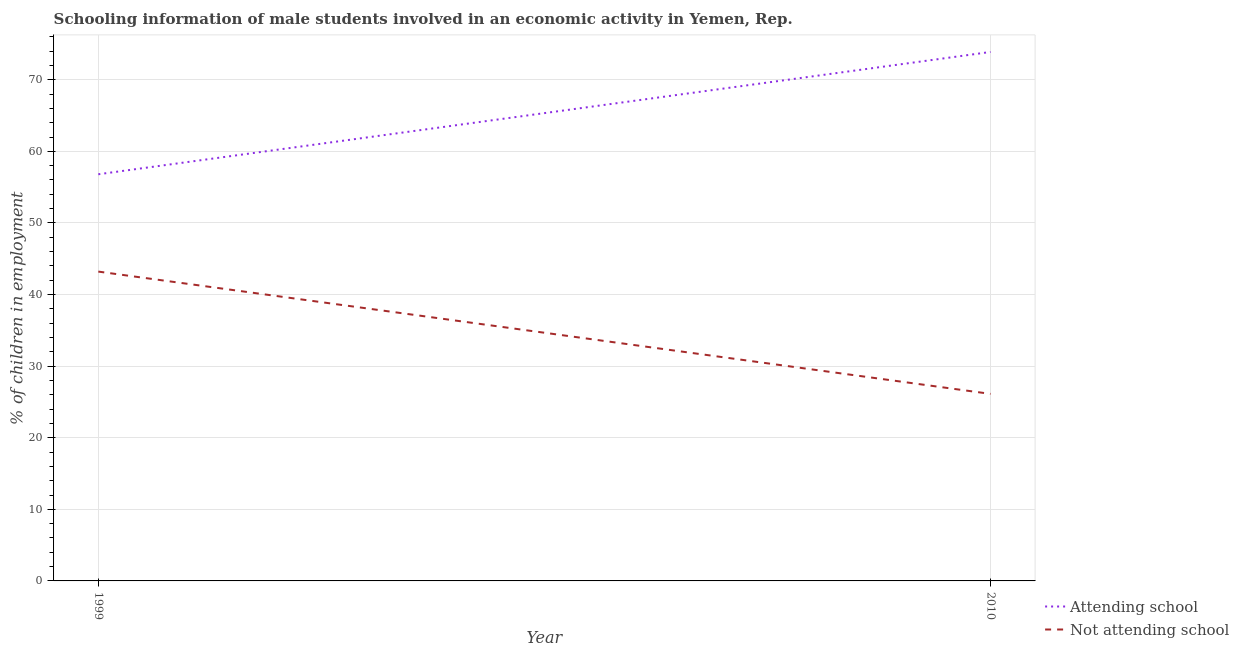What is the percentage of employed males who are not attending school in 2010?
Your response must be concise. 26.12. Across all years, what is the maximum percentage of employed males who are not attending school?
Ensure brevity in your answer.  43.2. Across all years, what is the minimum percentage of employed males who are attending school?
Your answer should be compact. 56.8. What is the total percentage of employed males who are attending school in the graph?
Provide a succinct answer. 130.67. What is the difference between the percentage of employed males who are attending school in 1999 and that in 2010?
Provide a succinct answer. -17.08. What is the difference between the percentage of employed males who are not attending school in 2010 and the percentage of employed males who are attending school in 1999?
Provide a succinct answer. -30.67. What is the average percentage of employed males who are attending school per year?
Give a very brief answer. 65.34. In the year 2010, what is the difference between the percentage of employed males who are attending school and percentage of employed males who are not attending school?
Keep it short and to the point. 47.76. In how many years, is the percentage of employed males who are not attending school greater than 26 %?
Your answer should be very brief. 2. What is the ratio of the percentage of employed males who are attending school in 1999 to that in 2010?
Provide a short and direct response. 0.77. Is the percentage of employed males who are not attending school in 1999 less than that in 2010?
Ensure brevity in your answer.  No. In how many years, is the percentage of employed males who are attending school greater than the average percentage of employed males who are attending school taken over all years?
Provide a succinct answer. 1. Is the percentage of employed males who are attending school strictly less than the percentage of employed males who are not attending school over the years?
Your answer should be compact. No. Does the graph contain any zero values?
Provide a succinct answer. No. Does the graph contain grids?
Keep it short and to the point. Yes. How many legend labels are there?
Offer a terse response. 2. How are the legend labels stacked?
Provide a succinct answer. Vertical. What is the title of the graph?
Your answer should be compact. Schooling information of male students involved in an economic activity in Yemen, Rep. Does "Register a business" appear as one of the legend labels in the graph?
Offer a terse response. No. What is the label or title of the X-axis?
Your answer should be very brief. Year. What is the label or title of the Y-axis?
Provide a succinct answer. % of children in employment. What is the % of children in employment in Attending school in 1999?
Ensure brevity in your answer.  56.8. What is the % of children in employment in Not attending school in 1999?
Provide a short and direct response. 43.2. What is the % of children in employment of Attending school in 2010?
Your answer should be compact. 73.88. What is the % of children in employment in Not attending school in 2010?
Offer a terse response. 26.12. Across all years, what is the maximum % of children in employment in Attending school?
Provide a short and direct response. 73.88. Across all years, what is the maximum % of children in employment in Not attending school?
Offer a very short reply. 43.2. Across all years, what is the minimum % of children in employment of Attending school?
Ensure brevity in your answer.  56.8. Across all years, what is the minimum % of children in employment of Not attending school?
Offer a terse response. 26.12. What is the total % of children in employment in Attending school in the graph?
Provide a short and direct response. 130.67. What is the total % of children in employment in Not attending school in the graph?
Make the answer very short. 69.33. What is the difference between the % of children in employment in Attending school in 1999 and that in 2010?
Provide a succinct answer. -17.08. What is the difference between the % of children in employment of Not attending school in 1999 and that in 2010?
Your answer should be compact. 17.08. What is the difference between the % of children in employment of Attending school in 1999 and the % of children in employment of Not attending school in 2010?
Your answer should be compact. 30.67. What is the average % of children in employment of Attending school per year?
Give a very brief answer. 65.34. What is the average % of children in employment of Not attending school per year?
Provide a succinct answer. 34.66. In the year 1999, what is the difference between the % of children in employment in Attending school and % of children in employment in Not attending school?
Your answer should be compact. 13.59. In the year 2010, what is the difference between the % of children in employment in Attending school and % of children in employment in Not attending school?
Make the answer very short. 47.76. What is the ratio of the % of children in employment in Attending school in 1999 to that in 2010?
Make the answer very short. 0.77. What is the ratio of the % of children in employment of Not attending school in 1999 to that in 2010?
Give a very brief answer. 1.65. What is the difference between the highest and the second highest % of children in employment of Attending school?
Your answer should be very brief. 17.08. What is the difference between the highest and the second highest % of children in employment in Not attending school?
Offer a terse response. 17.08. What is the difference between the highest and the lowest % of children in employment of Attending school?
Your response must be concise. 17.08. What is the difference between the highest and the lowest % of children in employment in Not attending school?
Keep it short and to the point. 17.08. 